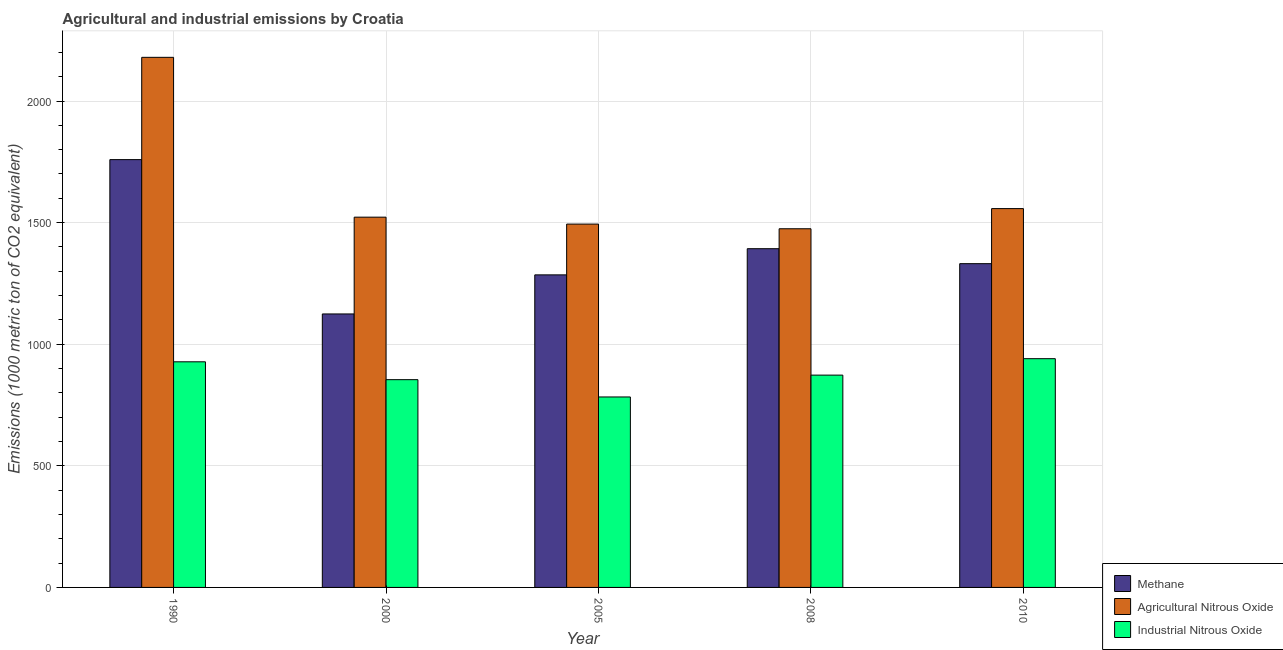How many different coloured bars are there?
Your answer should be compact. 3. How many groups of bars are there?
Your answer should be compact. 5. How many bars are there on the 4th tick from the right?
Make the answer very short. 3. What is the label of the 2nd group of bars from the left?
Your response must be concise. 2000. In how many cases, is the number of bars for a given year not equal to the number of legend labels?
Make the answer very short. 0. What is the amount of methane emissions in 2005?
Ensure brevity in your answer.  1285.2. Across all years, what is the maximum amount of agricultural nitrous oxide emissions?
Your response must be concise. 2179.7. Across all years, what is the minimum amount of methane emissions?
Your response must be concise. 1124.5. In which year was the amount of agricultural nitrous oxide emissions maximum?
Provide a short and direct response. 1990. What is the total amount of agricultural nitrous oxide emissions in the graph?
Your answer should be compact. 8228.7. What is the difference between the amount of agricultural nitrous oxide emissions in 1990 and that in 2005?
Provide a succinct answer. 685.7. What is the difference between the amount of industrial nitrous oxide emissions in 2000 and the amount of methane emissions in 2010?
Your answer should be compact. -86.3. What is the average amount of methane emissions per year?
Offer a terse response. 1378.58. In how many years, is the amount of industrial nitrous oxide emissions greater than 2000 metric ton?
Give a very brief answer. 0. What is the ratio of the amount of methane emissions in 2000 to that in 2010?
Your response must be concise. 0.84. What is the difference between the highest and the second highest amount of industrial nitrous oxide emissions?
Ensure brevity in your answer.  12.9. What is the difference between the highest and the lowest amount of industrial nitrous oxide emissions?
Give a very brief answer. 157.4. In how many years, is the amount of industrial nitrous oxide emissions greater than the average amount of industrial nitrous oxide emissions taken over all years?
Your answer should be compact. 2. Is the sum of the amount of industrial nitrous oxide emissions in 2008 and 2010 greater than the maximum amount of agricultural nitrous oxide emissions across all years?
Offer a very short reply. Yes. What does the 2nd bar from the left in 2008 represents?
Keep it short and to the point. Agricultural Nitrous Oxide. What does the 1st bar from the right in 2000 represents?
Your answer should be very brief. Industrial Nitrous Oxide. How many bars are there?
Your response must be concise. 15. How many years are there in the graph?
Offer a terse response. 5. Are the values on the major ticks of Y-axis written in scientific E-notation?
Your answer should be compact. No. Does the graph contain any zero values?
Provide a short and direct response. No. Where does the legend appear in the graph?
Your answer should be compact. Bottom right. How are the legend labels stacked?
Your response must be concise. Vertical. What is the title of the graph?
Your answer should be compact. Agricultural and industrial emissions by Croatia. What is the label or title of the Y-axis?
Make the answer very short. Emissions (1000 metric ton of CO2 equivalent). What is the Emissions (1000 metric ton of CO2 equivalent) in Methane in 1990?
Your answer should be very brief. 1759.1. What is the Emissions (1000 metric ton of CO2 equivalent) in Agricultural Nitrous Oxide in 1990?
Offer a very short reply. 2179.7. What is the Emissions (1000 metric ton of CO2 equivalent) in Industrial Nitrous Oxide in 1990?
Give a very brief answer. 927.7. What is the Emissions (1000 metric ton of CO2 equivalent) in Methane in 2000?
Your answer should be very brief. 1124.5. What is the Emissions (1000 metric ton of CO2 equivalent) in Agricultural Nitrous Oxide in 2000?
Keep it short and to the point. 1522.5. What is the Emissions (1000 metric ton of CO2 equivalent) of Industrial Nitrous Oxide in 2000?
Offer a terse response. 854.3. What is the Emissions (1000 metric ton of CO2 equivalent) of Methane in 2005?
Keep it short and to the point. 1285.2. What is the Emissions (1000 metric ton of CO2 equivalent) of Agricultural Nitrous Oxide in 2005?
Your answer should be compact. 1494. What is the Emissions (1000 metric ton of CO2 equivalent) of Industrial Nitrous Oxide in 2005?
Give a very brief answer. 783.2. What is the Emissions (1000 metric ton of CO2 equivalent) in Methane in 2008?
Offer a terse response. 1392.8. What is the Emissions (1000 metric ton of CO2 equivalent) of Agricultural Nitrous Oxide in 2008?
Ensure brevity in your answer.  1474.8. What is the Emissions (1000 metric ton of CO2 equivalent) in Industrial Nitrous Oxide in 2008?
Provide a succinct answer. 873. What is the Emissions (1000 metric ton of CO2 equivalent) in Methane in 2010?
Offer a terse response. 1331.3. What is the Emissions (1000 metric ton of CO2 equivalent) in Agricultural Nitrous Oxide in 2010?
Make the answer very short. 1557.7. What is the Emissions (1000 metric ton of CO2 equivalent) in Industrial Nitrous Oxide in 2010?
Make the answer very short. 940.6. Across all years, what is the maximum Emissions (1000 metric ton of CO2 equivalent) of Methane?
Keep it short and to the point. 1759.1. Across all years, what is the maximum Emissions (1000 metric ton of CO2 equivalent) in Agricultural Nitrous Oxide?
Your answer should be compact. 2179.7. Across all years, what is the maximum Emissions (1000 metric ton of CO2 equivalent) of Industrial Nitrous Oxide?
Provide a succinct answer. 940.6. Across all years, what is the minimum Emissions (1000 metric ton of CO2 equivalent) of Methane?
Provide a succinct answer. 1124.5. Across all years, what is the minimum Emissions (1000 metric ton of CO2 equivalent) in Agricultural Nitrous Oxide?
Ensure brevity in your answer.  1474.8. Across all years, what is the minimum Emissions (1000 metric ton of CO2 equivalent) in Industrial Nitrous Oxide?
Keep it short and to the point. 783.2. What is the total Emissions (1000 metric ton of CO2 equivalent) of Methane in the graph?
Keep it short and to the point. 6892.9. What is the total Emissions (1000 metric ton of CO2 equivalent) of Agricultural Nitrous Oxide in the graph?
Offer a very short reply. 8228.7. What is the total Emissions (1000 metric ton of CO2 equivalent) of Industrial Nitrous Oxide in the graph?
Make the answer very short. 4378.8. What is the difference between the Emissions (1000 metric ton of CO2 equivalent) of Methane in 1990 and that in 2000?
Your answer should be very brief. 634.6. What is the difference between the Emissions (1000 metric ton of CO2 equivalent) in Agricultural Nitrous Oxide in 1990 and that in 2000?
Your answer should be compact. 657.2. What is the difference between the Emissions (1000 metric ton of CO2 equivalent) in Industrial Nitrous Oxide in 1990 and that in 2000?
Provide a succinct answer. 73.4. What is the difference between the Emissions (1000 metric ton of CO2 equivalent) of Methane in 1990 and that in 2005?
Your answer should be compact. 473.9. What is the difference between the Emissions (1000 metric ton of CO2 equivalent) of Agricultural Nitrous Oxide in 1990 and that in 2005?
Provide a succinct answer. 685.7. What is the difference between the Emissions (1000 metric ton of CO2 equivalent) in Industrial Nitrous Oxide in 1990 and that in 2005?
Offer a very short reply. 144.5. What is the difference between the Emissions (1000 metric ton of CO2 equivalent) of Methane in 1990 and that in 2008?
Offer a terse response. 366.3. What is the difference between the Emissions (1000 metric ton of CO2 equivalent) of Agricultural Nitrous Oxide in 1990 and that in 2008?
Your response must be concise. 704.9. What is the difference between the Emissions (1000 metric ton of CO2 equivalent) in Industrial Nitrous Oxide in 1990 and that in 2008?
Provide a succinct answer. 54.7. What is the difference between the Emissions (1000 metric ton of CO2 equivalent) of Methane in 1990 and that in 2010?
Provide a short and direct response. 427.8. What is the difference between the Emissions (1000 metric ton of CO2 equivalent) in Agricultural Nitrous Oxide in 1990 and that in 2010?
Ensure brevity in your answer.  622. What is the difference between the Emissions (1000 metric ton of CO2 equivalent) in Industrial Nitrous Oxide in 1990 and that in 2010?
Provide a succinct answer. -12.9. What is the difference between the Emissions (1000 metric ton of CO2 equivalent) of Methane in 2000 and that in 2005?
Ensure brevity in your answer.  -160.7. What is the difference between the Emissions (1000 metric ton of CO2 equivalent) in Agricultural Nitrous Oxide in 2000 and that in 2005?
Your answer should be compact. 28.5. What is the difference between the Emissions (1000 metric ton of CO2 equivalent) in Industrial Nitrous Oxide in 2000 and that in 2005?
Keep it short and to the point. 71.1. What is the difference between the Emissions (1000 metric ton of CO2 equivalent) in Methane in 2000 and that in 2008?
Keep it short and to the point. -268.3. What is the difference between the Emissions (1000 metric ton of CO2 equivalent) of Agricultural Nitrous Oxide in 2000 and that in 2008?
Offer a very short reply. 47.7. What is the difference between the Emissions (1000 metric ton of CO2 equivalent) of Industrial Nitrous Oxide in 2000 and that in 2008?
Keep it short and to the point. -18.7. What is the difference between the Emissions (1000 metric ton of CO2 equivalent) of Methane in 2000 and that in 2010?
Provide a succinct answer. -206.8. What is the difference between the Emissions (1000 metric ton of CO2 equivalent) in Agricultural Nitrous Oxide in 2000 and that in 2010?
Your answer should be very brief. -35.2. What is the difference between the Emissions (1000 metric ton of CO2 equivalent) in Industrial Nitrous Oxide in 2000 and that in 2010?
Give a very brief answer. -86.3. What is the difference between the Emissions (1000 metric ton of CO2 equivalent) of Methane in 2005 and that in 2008?
Your answer should be very brief. -107.6. What is the difference between the Emissions (1000 metric ton of CO2 equivalent) in Industrial Nitrous Oxide in 2005 and that in 2008?
Ensure brevity in your answer.  -89.8. What is the difference between the Emissions (1000 metric ton of CO2 equivalent) in Methane in 2005 and that in 2010?
Give a very brief answer. -46.1. What is the difference between the Emissions (1000 metric ton of CO2 equivalent) in Agricultural Nitrous Oxide in 2005 and that in 2010?
Keep it short and to the point. -63.7. What is the difference between the Emissions (1000 metric ton of CO2 equivalent) of Industrial Nitrous Oxide in 2005 and that in 2010?
Provide a succinct answer. -157.4. What is the difference between the Emissions (1000 metric ton of CO2 equivalent) of Methane in 2008 and that in 2010?
Provide a short and direct response. 61.5. What is the difference between the Emissions (1000 metric ton of CO2 equivalent) of Agricultural Nitrous Oxide in 2008 and that in 2010?
Your answer should be compact. -82.9. What is the difference between the Emissions (1000 metric ton of CO2 equivalent) in Industrial Nitrous Oxide in 2008 and that in 2010?
Keep it short and to the point. -67.6. What is the difference between the Emissions (1000 metric ton of CO2 equivalent) in Methane in 1990 and the Emissions (1000 metric ton of CO2 equivalent) in Agricultural Nitrous Oxide in 2000?
Your answer should be compact. 236.6. What is the difference between the Emissions (1000 metric ton of CO2 equivalent) in Methane in 1990 and the Emissions (1000 metric ton of CO2 equivalent) in Industrial Nitrous Oxide in 2000?
Make the answer very short. 904.8. What is the difference between the Emissions (1000 metric ton of CO2 equivalent) of Agricultural Nitrous Oxide in 1990 and the Emissions (1000 metric ton of CO2 equivalent) of Industrial Nitrous Oxide in 2000?
Provide a succinct answer. 1325.4. What is the difference between the Emissions (1000 metric ton of CO2 equivalent) in Methane in 1990 and the Emissions (1000 metric ton of CO2 equivalent) in Agricultural Nitrous Oxide in 2005?
Offer a terse response. 265.1. What is the difference between the Emissions (1000 metric ton of CO2 equivalent) of Methane in 1990 and the Emissions (1000 metric ton of CO2 equivalent) of Industrial Nitrous Oxide in 2005?
Ensure brevity in your answer.  975.9. What is the difference between the Emissions (1000 metric ton of CO2 equivalent) of Agricultural Nitrous Oxide in 1990 and the Emissions (1000 metric ton of CO2 equivalent) of Industrial Nitrous Oxide in 2005?
Provide a succinct answer. 1396.5. What is the difference between the Emissions (1000 metric ton of CO2 equivalent) in Methane in 1990 and the Emissions (1000 metric ton of CO2 equivalent) in Agricultural Nitrous Oxide in 2008?
Your response must be concise. 284.3. What is the difference between the Emissions (1000 metric ton of CO2 equivalent) of Methane in 1990 and the Emissions (1000 metric ton of CO2 equivalent) of Industrial Nitrous Oxide in 2008?
Your response must be concise. 886.1. What is the difference between the Emissions (1000 metric ton of CO2 equivalent) of Agricultural Nitrous Oxide in 1990 and the Emissions (1000 metric ton of CO2 equivalent) of Industrial Nitrous Oxide in 2008?
Provide a short and direct response. 1306.7. What is the difference between the Emissions (1000 metric ton of CO2 equivalent) in Methane in 1990 and the Emissions (1000 metric ton of CO2 equivalent) in Agricultural Nitrous Oxide in 2010?
Provide a short and direct response. 201.4. What is the difference between the Emissions (1000 metric ton of CO2 equivalent) in Methane in 1990 and the Emissions (1000 metric ton of CO2 equivalent) in Industrial Nitrous Oxide in 2010?
Your answer should be very brief. 818.5. What is the difference between the Emissions (1000 metric ton of CO2 equivalent) of Agricultural Nitrous Oxide in 1990 and the Emissions (1000 metric ton of CO2 equivalent) of Industrial Nitrous Oxide in 2010?
Keep it short and to the point. 1239.1. What is the difference between the Emissions (1000 metric ton of CO2 equivalent) of Methane in 2000 and the Emissions (1000 metric ton of CO2 equivalent) of Agricultural Nitrous Oxide in 2005?
Offer a terse response. -369.5. What is the difference between the Emissions (1000 metric ton of CO2 equivalent) in Methane in 2000 and the Emissions (1000 metric ton of CO2 equivalent) in Industrial Nitrous Oxide in 2005?
Provide a short and direct response. 341.3. What is the difference between the Emissions (1000 metric ton of CO2 equivalent) of Agricultural Nitrous Oxide in 2000 and the Emissions (1000 metric ton of CO2 equivalent) of Industrial Nitrous Oxide in 2005?
Ensure brevity in your answer.  739.3. What is the difference between the Emissions (1000 metric ton of CO2 equivalent) in Methane in 2000 and the Emissions (1000 metric ton of CO2 equivalent) in Agricultural Nitrous Oxide in 2008?
Ensure brevity in your answer.  -350.3. What is the difference between the Emissions (1000 metric ton of CO2 equivalent) of Methane in 2000 and the Emissions (1000 metric ton of CO2 equivalent) of Industrial Nitrous Oxide in 2008?
Give a very brief answer. 251.5. What is the difference between the Emissions (1000 metric ton of CO2 equivalent) of Agricultural Nitrous Oxide in 2000 and the Emissions (1000 metric ton of CO2 equivalent) of Industrial Nitrous Oxide in 2008?
Offer a terse response. 649.5. What is the difference between the Emissions (1000 metric ton of CO2 equivalent) in Methane in 2000 and the Emissions (1000 metric ton of CO2 equivalent) in Agricultural Nitrous Oxide in 2010?
Your answer should be very brief. -433.2. What is the difference between the Emissions (1000 metric ton of CO2 equivalent) in Methane in 2000 and the Emissions (1000 metric ton of CO2 equivalent) in Industrial Nitrous Oxide in 2010?
Ensure brevity in your answer.  183.9. What is the difference between the Emissions (1000 metric ton of CO2 equivalent) of Agricultural Nitrous Oxide in 2000 and the Emissions (1000 metric ton of CO2 equivalent) of Industrial Nitrous Oxide in 2010?
Offer a very short reply. 581.9. What is the difference between the Emissions (1000 metric ton of CO2 equivalent) of Methane in 2005 and the Emissions (1000 metric ton of CO2 equivalent) of Agricultural Nitrous Oxide in 2008?
Provide a succinct answer. -189.6. What is the difference between the Emissions (1000 metric ton of CO2 equivalent) of Methane in 2005 and the Emissions (1000 metric ton of CO2 equivalent) of Industrial Nitrous Oxide in 2008?
Your response must be concise. 412.2. What is the difference between the Emissions (1000 metric ton of CO2 equivalent) of Agricultural Nitrous Oxide in 2005 and the Emissions (1000 metric ton of CO2 equivalent) of Industrial Nitrous Oxide in 2008?
Your response must be concise. 621. What is the difference between the Emissions (1000 metric ton of CO2 equivalent) in Methane in 2005 and the Emissions (1000 metric ton of CO2 equivalent) in Agricultural Nitrous Oxide in 2010?
Ensure brevity in your answer.  -272.5. What is the difference between the Emissions (1000 metric ton of CO2 equivalent) of Methane in 2005 and the Emissions (1000 metric ton of CO2 equivalent) of Industrial Nitrous Oxide in 2010?
Ensure brevity in your answer.  344.6. What is the difference between the Emissions (1000 metric ton of CO2 equivalent) of Agricultural Nitrous Oxide in 2005 and the Emissions (1000 metric ton of CO2 equivalent) of Industrial Nitrous Oxide in 2010?
Provide a short and direct response. 553.4. What is the difference between the Emissions (1000 metric ton of CO2 equivalent) in Methane in 2008 and the Emissions (1000 metric ton of CO2 equivalent) in Agricultural Nitrous Oxide in 2010?
Your answer should be very brief. -164.9. What is the difference between the Emissions (1000 metric ton of CO2 equivalent) of Methane in 2008 and the Emissions (1000 metric ton of CO2 equivalent) of Industrial Nitrous Oxide in 2010?
Your answer should be very brief. 452.2. What is the difference between the Emissions (1000 metric ton of CO2 equivalent) in Agricultural Nitrous Oxide in 2008 and the Emissions (1000 metric ton of CO2 equivalent) in Industrial Nitrous Oxide in 2010?
Ensure brevity in your answer.  534.2. What is the average Emissions (1000 metric ton of CO2 equivalent) of Methane per year?
Give a very brief answer. 1378.58. What is the average Emissions (1000 metric ton of CO2 equivalent) in Agricultural Nitrous Oxide per year?
Offer a very short reply. 1645.74. What is the average Emissions (1000 metric ton of CO2 equivalent) of Industrial Nitrous Oxide per year?
Ensure brevity in your answer.  875.76. In the year 1990, what is the difference between the Emissions (1000 metric ton of CO2 equivalent) in Methane and Emissions (1000 metric ton of CO2 equivalent) in Agricultural Nitrous Oxide?
Keep it short and to the point. -420.6. In the year 1990, what is the difference between the Emissions (1000 metric ton of CO2 equivalent) in Methane and Emissions (1000 metric ton of CO2 equivalent) in Industrial Nitrous Oxide?
Your response must be concise. 831.4. In the year 1990, what is the difference between the Emissions (1000 metric ton of CO2 equivalent) of Agricultural Nitrous Oxide and Emissions (1000 metric ton of CO2 equivalent) of Industrial Nitrous Oxide?
Ensure brevity in your answer.  1252. In the year 2000, what is the difference between the Emissions (1000 metric ton of CO2 equivalent) of Methane and Emissions (1000 metric ton of CO2 equivalent) of Agricultural Nitrous Oxide?
Keep it short and to the point. -398. In the year 2000, what is the difference between the Emissions (1000 metric ton of CO2 equivalent) of Methane and Emissions (1000 metric ton of CO2 equivalent) of Industrial Nitrous Oxide?
Offer a terse response. 270.2. In the year 2000, what is the difference between the Emissions (1000 metric ton of CO2 equivalent) in Agricultural Nitrous Oxide and Emissions (1000 metric ton of CO2 equivalent) in Industrial Nitrous Oxide?
Offer a terse response. 668.2. In the year 2005, what is the difference between the Emissions (1000 metric ton of CO2 equivalent) of Methane and Emissions (1000 metric ton of CO2 equivalent) of Agricultural Nitrous Oxide?
Provide a short and direct response. -208.8. In the year 2005, what is the difference between the Emissions (1000 metric ton of CO2 equivalent) of Methane and Emissions (1000 metric ton of CO2 equivalent) of Industrial Nitrous Oxide?
Ensure brevity in your answer.  502. In the year 2005, what is the difference between the Emissions (1000 metric ton of CO2 equivalent) of Agricultural Nitrous Oxide and Emissions (1000 metric ton of CO2 equivalent) of Industrial Nitrous Oxide?
Make the answer very short. 710.8. In the year 2008, what is the difference between the Emissions (1000 metric ton of CO2 equivalent) in Methane and Emissions (1000 metric ton of CO2 equivalent) in Agricultural Nitrous Oxide?
Keep it short and to the point. -82. In the year 2008, what is the difference between the Emissions (1000 metric ton of CO2 equivalent) in Methane and Emissions (1000 metric ton of CO2 equivalent) in Industrial Nitrous Oxide?
Offer a terse response. 519.8. In the year 2008, what is the difference between the Emissions (1000 metric ton of CO2 equivalent) of Agricultural Nitrous Oxide and Emissions (1000 metric ton of CO2 equivalent) of Industrial Nitrous Oxide?
Offer a very short reply. 601.8. In the year 2010, what is the difference between the Emissions (1000 metric ton of CO2 equivalent) of Methane and Emissions (1000 metric ton of CO2 equivalent) of Agricultural Nitrous Oxide?
Your response must be concise. -226.4. In the year 2010, what is the difference between the Emissions (1000 metric ton of CO2 equivalent) of Methane and Emissions (1000 metric ton of CO2 equivalent) of Industrial Nitrous Oxide?
Give a very brief answer. 390.7. In the year 2010, what is the difference between the Emissions (1000 metric ton of CO2 equivalent) of Agricultural Nitrous Oxide and Emissions (1000 metric ton of CO2 equivalent) of Industrial Nitrous Oxide?
Offer a terse response. 617.1. What is the ratio of the Emissions (1000 metric ton of CO2 equivalent) of Methane in 1990 to that in 2000?
Offer a very short reply. 1.56. What is the ratio of the Emissions (1000 metric ton of CO2 equivalent) of Agricultural Nitrous Oxide in 1990 to that in 2000?
Ensure brevity in your answer.  1.43. What is the ratio of the Emissions (1000 metric ton of CO2 equivalent) of Industrial Nitrous Oxide in 1990 to that in 2000?
Provide a short and direct response. 1.09. What is the ratio of the Emissions (1000 metric ton of CO2 equivalent) in Methane in 1990 to that in 2005?
Offer a very short reply. 1.37. What is the ratio of the Emissions (1000 metric ton of CO2 equivalent) of Agricultural Nitrous Oxide in 1990 to that in 2005?
Offer a very short reply. 1.46. What is the ratio of the Emissions (1000 metric ton of CO2 equivalent) in Industrial Nitrous Oxide in 1990 to that in 2005?
Provide a succinct answer. 1.18. What is the ratio of the Emissions (1000 metric ton of CO2 equivalent) of Methane in 1990 to that in 2008?
Ensure brevity in your answer.  1.26. What is the ratio of the Emissions (1000 metric ton of CO2 equivalent) of Agricultural Nitrous Oxide in 1990 to that in 2008?
Give a very brief answer. 1.48. What is the ratio of the Emissions (1000 metric ton of CO2 equivalent) of Industrial Nitrous Oxide in 1990 to that in 2008?
Offer a terse response. 1.06. What is the ratio of the Emissions (1000 metric ton of CO2 equivalent) of Methane in 1990 to that in 2010?
Your response must be concise. 1.32. What is the ratio of the Emissions (1000 metric ton of CO2 equivalent) in Agricultural Nitrous Oxide in 1990 to that in 2010?
Your answer should be compact. 1.4. What is the ratio of the Emissions (1000 metric ton of CO2 equivalent) in Industrial Nitrous Oxide in 1990 to that in 2010?
Keep it short and to the point. 0.99. What is the ratio of the Emissions (1000 metric ton of CO2 equivalent) of Methane in 2000 to that in 2005?
Your answer should be very brief. 0.88. What is the ratio of the Emissions (1000 metric ton of CO2 equivalent) in Agricultural Nitrous Oxide in 2000 to that in 2005?
Your answer should be very brief. 1.02. What is the ratio of the Emissions (1000 metric ton of CO2 equivalent) in Industrial Nitrous Oxide in 2000 to that in 2005?
Offer a terse response. 1.09. What is the ratio of the Emissions (1000 metric ton of CO2 equivalent) of Methane in 2000 to that in 2008?
Your response must be concise. 0.81. What is the ratio of the Emissions (1000 metric ton of CO2 equivalent) of Agricultural Nitrous Oxide in 2000 to that in 2008?
Provide a succinct answer. 1.03. What is the ratio of the Emissions (1000 metric ton of CO2 equivalent) in Industrial Nitrous Oxide in 2000 to that in 2008?
Your answer should be very brief. 0.98. What is the ratio of the Emissions (1000 metric ton of CO2 equivalent) in Methane in 2000 to that in 2010?
Offer a very short reply. 0.84. What is the ratio of the Emissions (1000 metric ton of CO2 equivalent) in Agricultural Nitrous Oxide in 2000 to that in 2010?
Provide a succinct answer. 0.98. What is the ratio of the Emissions (1000 metric ton of CO2 equivalent) of Industrial Nitrous Oxide in 2000 to that in 2010?
Your answer should be very brief. 0.91. What is the ratio of the Emissions (1000 metric ton of CO2 equivalent) of Methane in 2005 to that in 2008?
Provide a succinct answer. 0.92. What is the ratio of the Emissions (1000 metric ton of CO2 equivalent) in Agricultural Nitrous Oxide in 2005 to that in 2008?
Provide a succinct answer. 1.01. What is the ratio of the Emissions (1000 metric ton of CO2 equivalent) in Industrial Nitrous Oxide in 2005 to that in 2008?
Keep it short and to the point. 0.9. What is the ratio of the Emissions (1000 metric ton of CO2 equivalent) in Methane in 2005 to that in 2010?
Offer a terse response. 0.97. What is the ratio of the Emissions (1000 metric ton of CO2 equivalent) of Agricultural Nitrous Oxide in 2005 to that in 2010?
Your answer should be compact. 0.96. What is the ratio of the Emissions (1000 metric ton of CO2 equivalent) in Industrial Nitrous Oxide in 2005 to that in 2010?
Offer a very short reply. 0.83. What is the ratio of the Emissions (1000 metric ton of CO2 equivalent) of Methane in 2008 to that in 2010?
Give a very brief answer. 1.05. What is the ratio of the Emissions (1000 metric ton of CO2 equivalent) of Agricultural Nitrous Oxide in 2008 to that in 2010?
Make the answer very short. 0.95. What is the ratio of the Emissions (1000 metric ton of CO2 equivalent) of Industrial Nitrous Oxide in 2008 to that in 2010?
Give a very brief answer. 0.93. What is the difference between the highest and the second highest Emissions (1000 metric ton of CO2 equivalent) of Methane?
Offer a very short reply. 366.3. What is the difference between the highest and the second highest Emissions (1000 metric ton of CO2 equivalent) of Agricultural Nitrous Oxide?
Provide a succinct answer. 622. What is the difference between the highest and the lowest Emissions (1000 metric ton of CO2 equivalent) of Methane?
Your answer should be compact. 634.6. What is the difference between the highest and the lowest Emissions (1000 metric ton of CO2 equivalent) of Agricultural Nitrous Oxide?
Your answer should be compact. 704.9. What is the difference between the highest and the lowest Emissions (1000 metric ton of CO2 equivalent) in Industrial Nitrous Oxide?
Offer a very short reply. 157.4. 